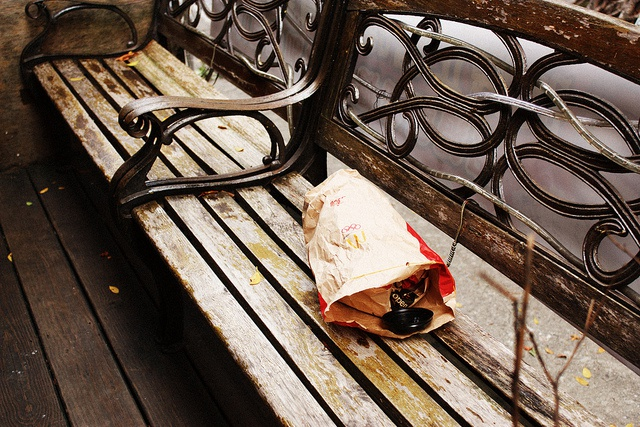Describe the objects in this image and their specific colors. I can see a bench in black, brown, lightgray, darkgray, and maroon tones in this image. 